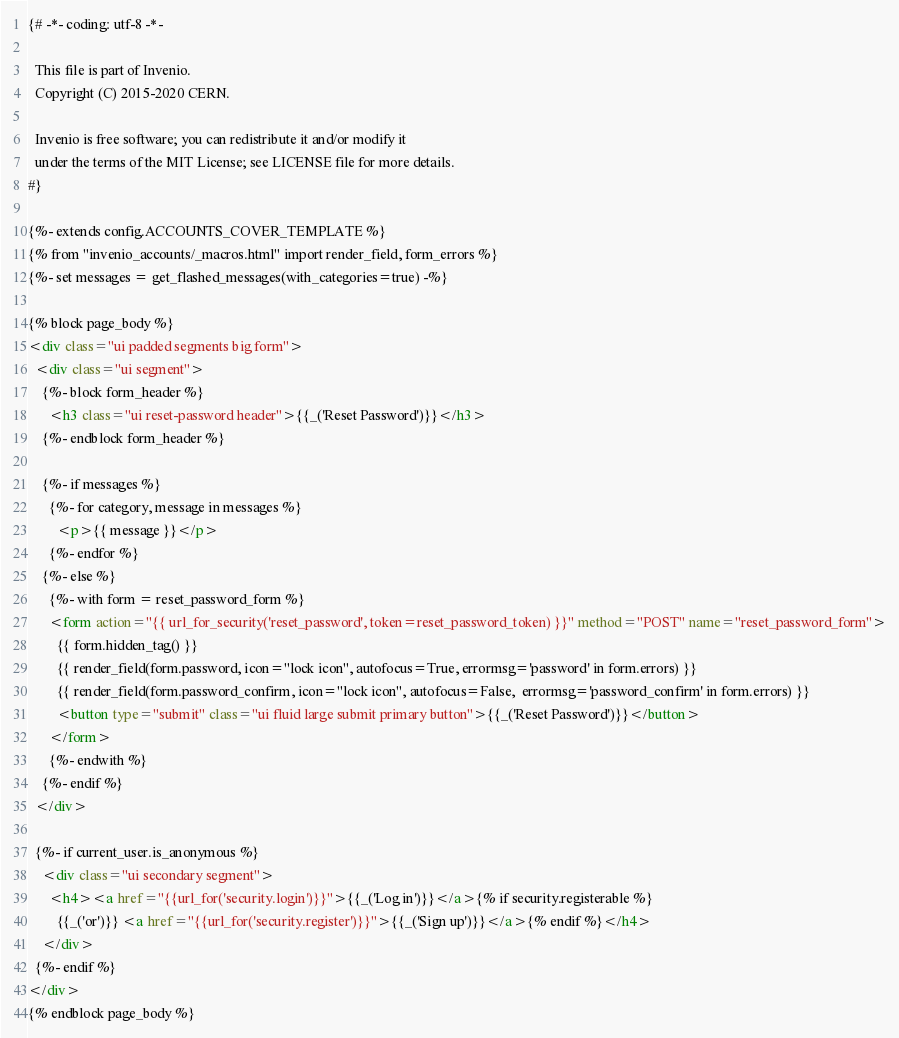<code> <loc_0><loc_0><loc_500><loc_500><_HTML_>{# -*- coding: utf-8 -*-

  This file is part of Invenio.
  Copyright (C) 2015-2020 CERN.

  Invenio is free software; you can redistribute it and/or modify it
  under the terms of the MIT License; see LICENSE file for more details.
#}

{%- extends config.ACCOUNTS_COVER_TEMPLATE %}
{% from "invenio_accounts/_macros.html" import render_field, form_errors %}
{%- set messages = get_flashed_messages(with_categories=true) -%}

{% block page_body %}
<div class="ui padded segments big form">
  <div class="ui segment">
    {%- block form_header %}
      <h3 class="ui reset-password header">{{_('Reset Password')}}</h3>
    {%- endblock form_header %}

    {%- if messages %}
      {%- for category, message in messages %}
        <p>{{ message }}</p>
      {%- endfor %}
    {%- else %}
      {%- with form = reset_password_form %}
      <form action="{{ url_for_security('reset_password', token=reset_password_token) }}" method="POST" name="reset_password_form">
        {{ form.hidden_tag() }}
        {{ render_field(form.password, icon="lock icon", autofocus=True, errormsg='password' in form.errors) }}
        {{ render_field(form.password_confirm, icon="lock icon", autofocus=False,  errormsg='password_confirm' in form.errors) }}
        <button type="submit" class="ui fluid large submit primary button">{{_('Reset Password')}}</button>
      </form>
      {%- endwith %}
    {%- endif %}
  </div>

  {%- if current_user.is_anonymous %}
    <div class="ui secondary segment">
      <h4><a href="{{url_for('security.login')}}">{{_('Log in')}}</a>{% if security.registerable %}
        {{_('or')}} <a href="{{url_for('security.register')}}">{{_('Sign up')}}</a>{% endif %}</h4>
    </div>
  {%- endif %}
</div>
{% endblock page_body %}
</code> 